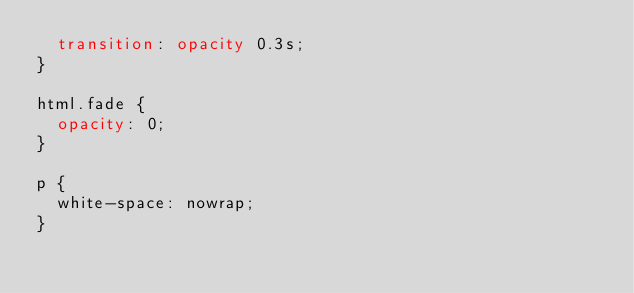<code> <loc_0><loc_0><loc_500><loc_500><_CSS_>  transition: opacity 0.3s;
}

html.fade {
  opacity: 0;
}

p {
  white-space: nowrap;
}
</code> 